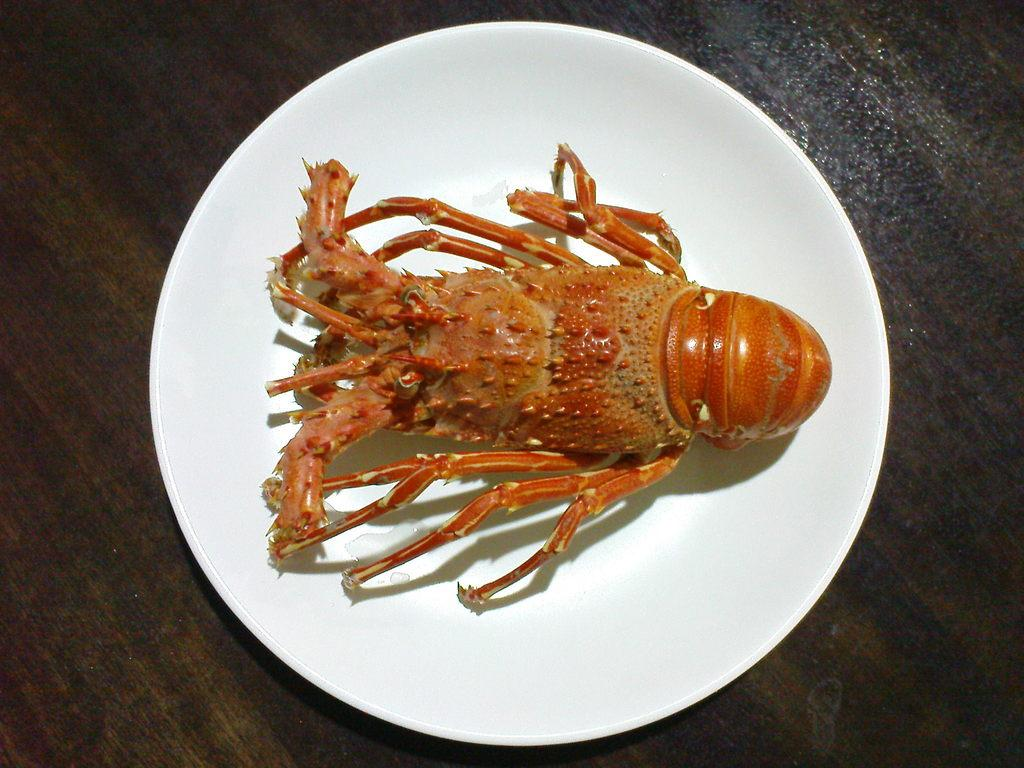What type of seafood can be seen in the image? There is a lobster in the image. How is the lobster presented in the image? The lobster is placed on a white plate. What can be seen in the background of the image? There is a wooden board in the background of the image. What type of magic is the lobster performing in the image? There is no magic or performance by the lobster in the image; it is simply placed on a white plate. 